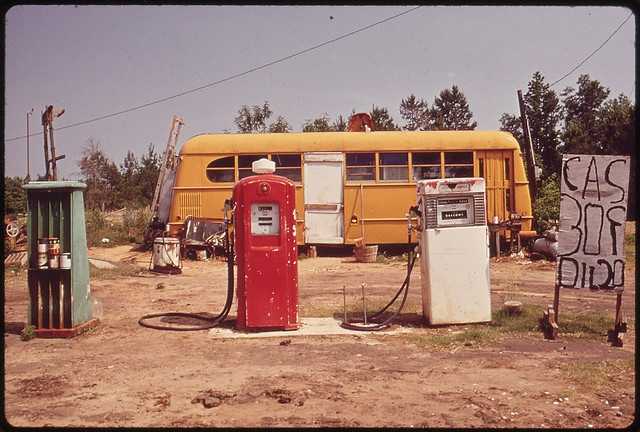Describe the objects in this image and their specific colors. I can see bus in black, orange, maroon, and brown tones in this image. 